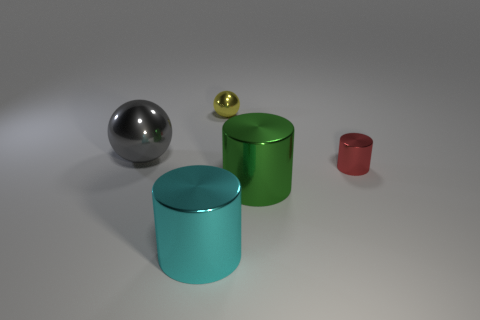There is a large green metallic thing behind the cylinder on the left side of the yellow ball; is there a tiny metallic object that is right of it?
Make the answer very short. Yes. Is the number of cyan cubes greater than the number of tiny balls?
Keep it short and to the point. No. There is a tiny shiny object that is in front of the large gray metal sphere; what color is it?
Ensure brevity in your answer.  Red. Is the number of big metallic cylinders behind the big cyan object greater than the number of big purple matte cylinders?
Provide a succinct answer. Yes. Are the big sphere and the yellow object made of the same material?
Provide a succinct answer. Yes. What number of other objects are there of the same shape as the yellow shiny object?
Provide a succinct answer. 1. Are there any other things that are the same material as the tiny red cylinder?
Your answer should be compact. Yes. What color is the big thing in front of the large object on the right side of the metallic ball on the right side of the large gray metallic object?
Offer a terse response. Cyan. There is a tiny thing that is right of the tiny yellow object; is its shape the same as the small yellow metallic object?
Provide a short and direct response. No. What number of large cyan metallic objects are there?
Provide a short and direct response. 1. 